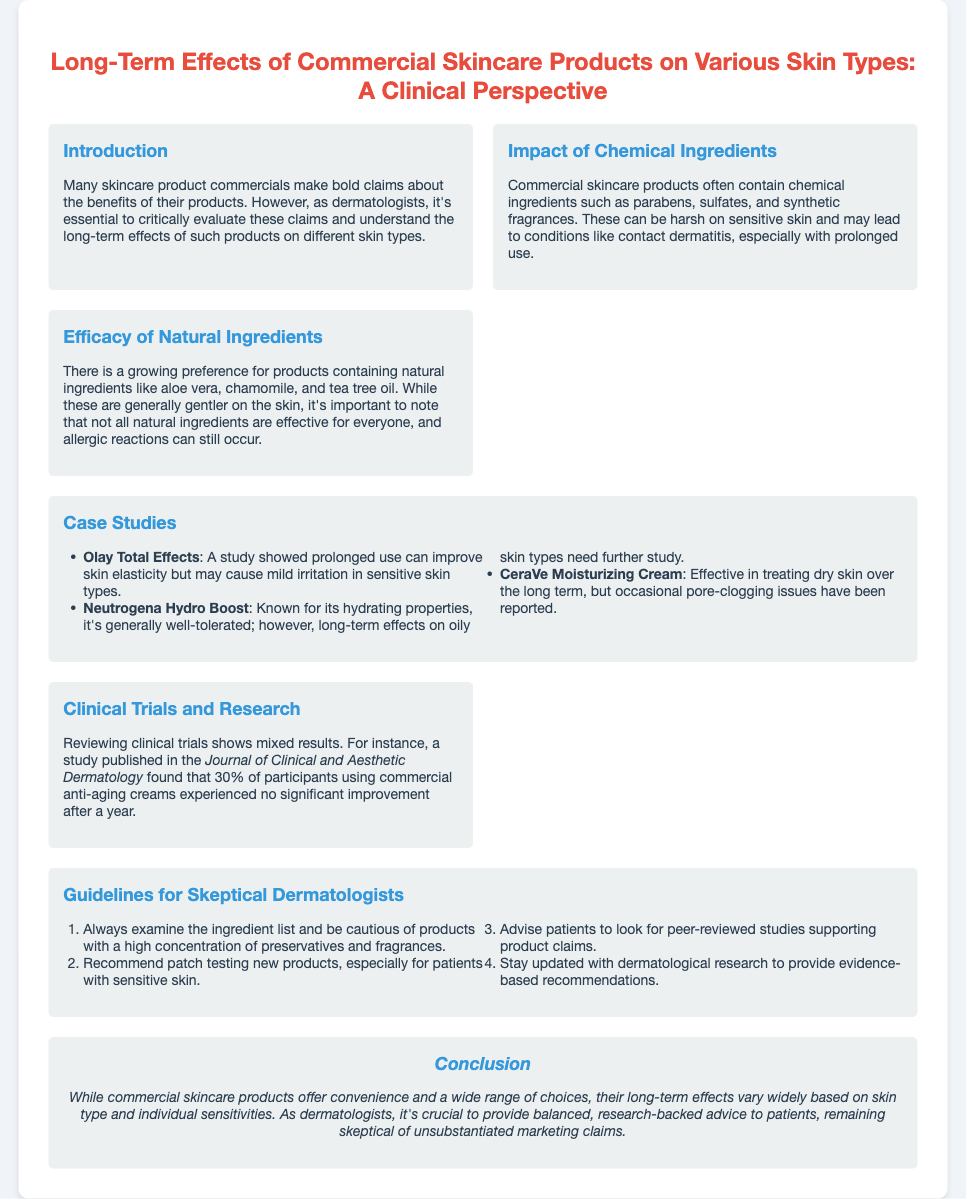What is the title of the presentation? The title is stated at the top of the document and provides the topic being discussed.
Answer: Long-Term Effects of Commercial Skincare Products on Various Skin Types: A Clinical Perspective What chemical ingredients are mentioned? The section discusses specific chemical ingredients that may be present in commercial skincare products.
Answer: Parabens, sulfates, synthetic fragrances Which natural ingredients are highlighted? The document lists natural ingredients preferred in skincare products.
Answer: Aloe vera, chamomile, tea tree oil How many case studies are presented? The number of distinct case studies listed under the case studies section provides this information.
Answer: Three What percentage of participants experienced no significant improvement with anti-aging creams? This percentage is derived from a study mentioned in the clinical trials section.
Answer: 30% What product is noted for treating dry skin effectively? This is indicated in the case studies section discussing specific product benefits.
Answer: CeraVe Moisturizing Cream What is one guideline for skeptical dermatologists? The guidelines provide steps dermatologists can follow to evaluate skincare products critically.
Answer: Examine the ingredient list In which publication was the study on commercial anti-aging creams found? This is sourced from the clinical trials and research section discussing the study's findings.
Answer: Journal of Clinical and Aesthetic Dermatology What is the overall conclusion regarding commercial skincare products? The conclusion summarizes the general stance on the efficacy and recommendations regarding skin products.
Answer: Vary widely based on skin type and individual sensitivities 